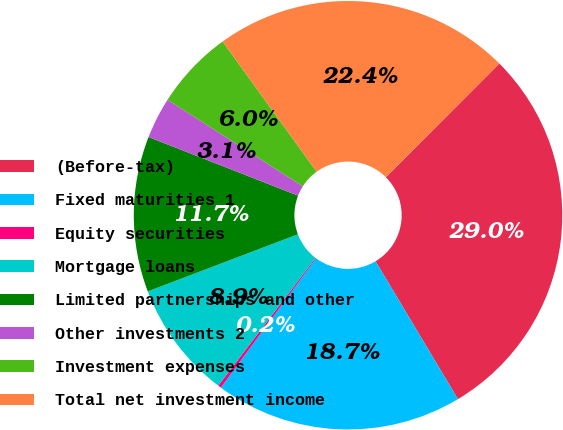Convert chart. <chart><loc_0><loc_0><loc_500><loc_500><pie_chart><fcel>(Before-tax)<fcel>Fixed maturities 1<fcel>Equity securities<fcel>Mortgage loans<fcel>Limited partnerships and other<fcel>Other investments 2<fcel>Investment expenses<fcel>Total net investment income<nl><fcel>28.95%<fcel>18.69%<fcel>0.24%<fcel>8.86%<fcel>11.73%<fcel>3.11%<fcel>5.99%<fcel>22.43%<nl></chart> 